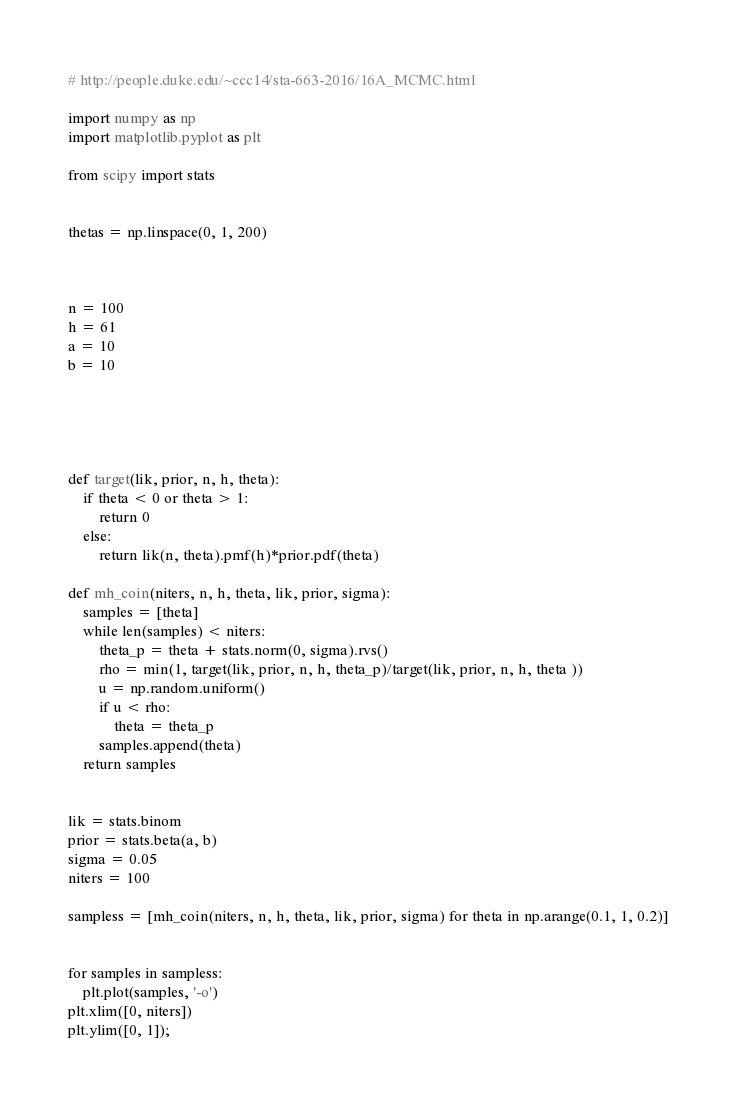Convert code to text. <code><loc_0><loc_0><loc_500><loc_500><_Python_>
# http://people.duke.edu/~ccc14/sta-663-2016/16A_MCMC.html

import numpy as np
import matplotlib.pyplot as plt

from scipy import stats


thetas = np.linspace(0, 1, 200)



n = 100
h = 61
a = 10
b = 10





def target(lik, prior, n, h, theta):
    if theta < 0 or theta > 1:
        return 0
    else:
        return lik(n, theta).pmf(h)*prior.pdf(theta)

def mh_coin(niters, n, h, theta, lik, prior, sigma):
    samples = [theta]
    while len(samples) < niters:
        theta_p = theta + stats.norm(0, sigma).rvs()
        rho = min(1, target(lik, prior, n, h, theta_p)/target(lik, prior, n, h, theta ))
        u = np.random.uniform()
        if u < rho:
            theta = theta_p
        samples.append(theta)
    return samples


lik = stats.binom
prior = stats.beta(a, b)
sigma = 0.05
niters = 100

sampless = [mh_coin(niters, n, h, theta, lik, prior, sigma) for theta in np.arange(0.1, 1, 0.2)]


for samples in sampless:
    plt.plot(samples, '-o')
plt.xlim([0, niters])
plt.ylim([0, 1]);</code> 